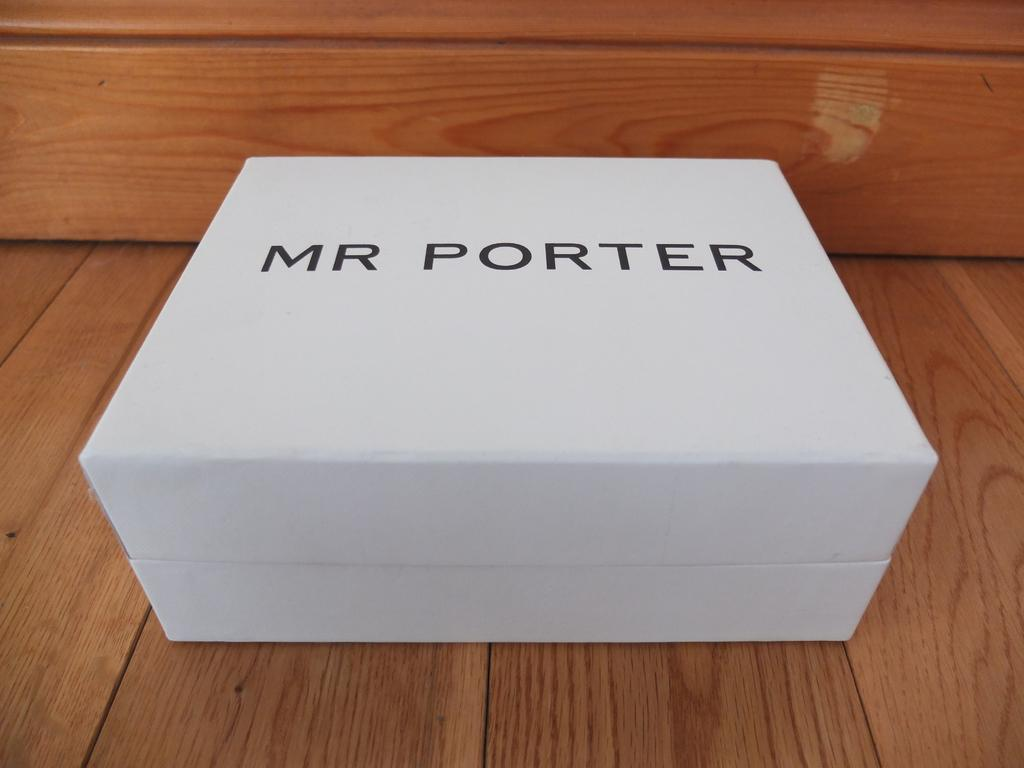<image>
Summarize the visual content of the image. Large white box that says Mr Porter on the top. 